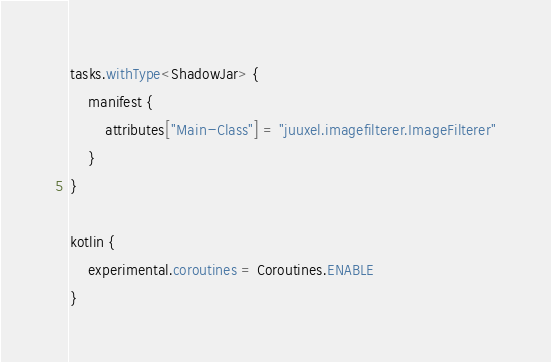Convert code to text. <code><loc_0><loc_0><loc_500><loc_500><_Kotlin_>tasks.withType<ShadowJar> {
    manifest {
        attributes["Main-Class"] = "juuxel.imagefilterer.ImageFilterer"
    }
}

kotlin {
    experimental.coroutines = Coroutines.ENABLE
}
</code> 